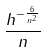Convert formula to latex. <formula><loc_0><loc_0><loc_500><loc_500>\frac { h ^ { - \frac { 6 } { n ^ { 2 } } } } { n }</formula> 